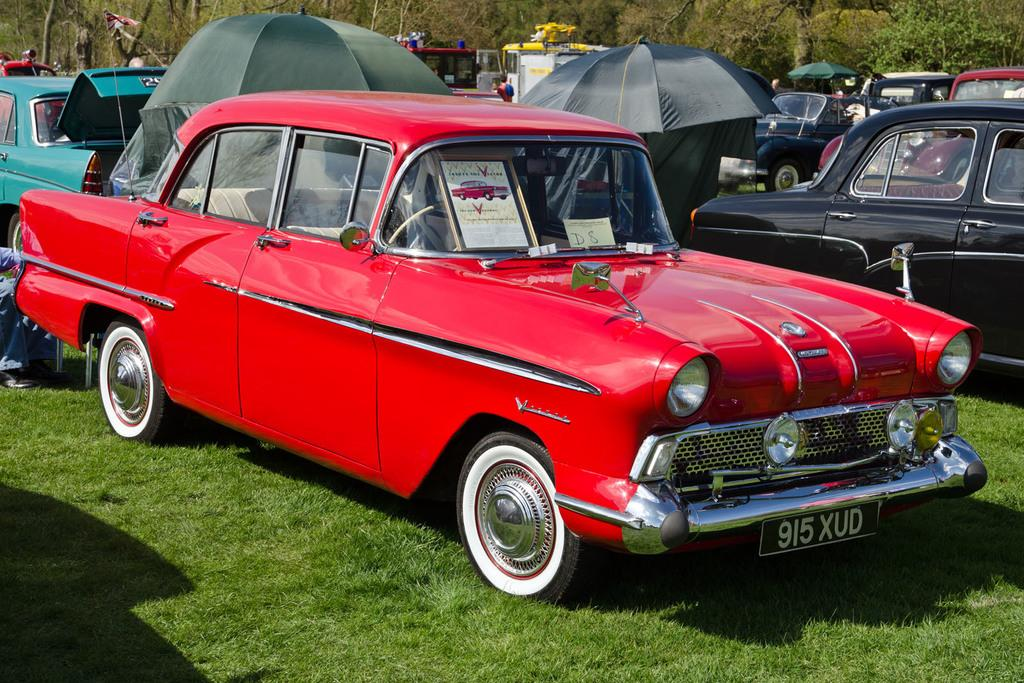What color is the car that is visible in the image? There is a red car in the image. How many cars can be seen in the image? There are many cars in the image. What objects are located in the middle of the image? There are two umbrellas in the middle of the image. What type of vegetation is at the bottom of the image? There is green grass at the bottom of the image. What can be seen in the background of the image? There are trees in the background of the image. How many babies are holding onto the red car in the image? There are no babies present in the image; it only features cars and umbrellas. What type of liquid is being poured from the umbrellas in the image? There is no liquid being poured from the umbrellas in the image; they are simply standing upright. 